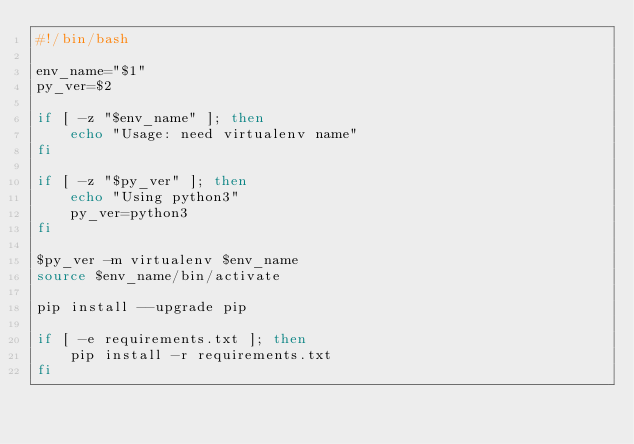Convert code to text. <code><loc_0><loc_0><loc_500><loc_500><_Bash_>#!/bin/bash

env_name="$1"
py_ver=$2

if [ -z "$env_name" ]; then
    echo "Usage: need virtualenv name"
fi

if [ -z "$py_ver" ]; then
    echo "Using python3"
    py_ver=python3
fi

$py_ver -m virtualenv $env_name
source $env_name/bin/activate

pip install --upgrade pip

if [ -e requirements.txt ]; then
    pip install -r requirements.txt
fi
</code> 